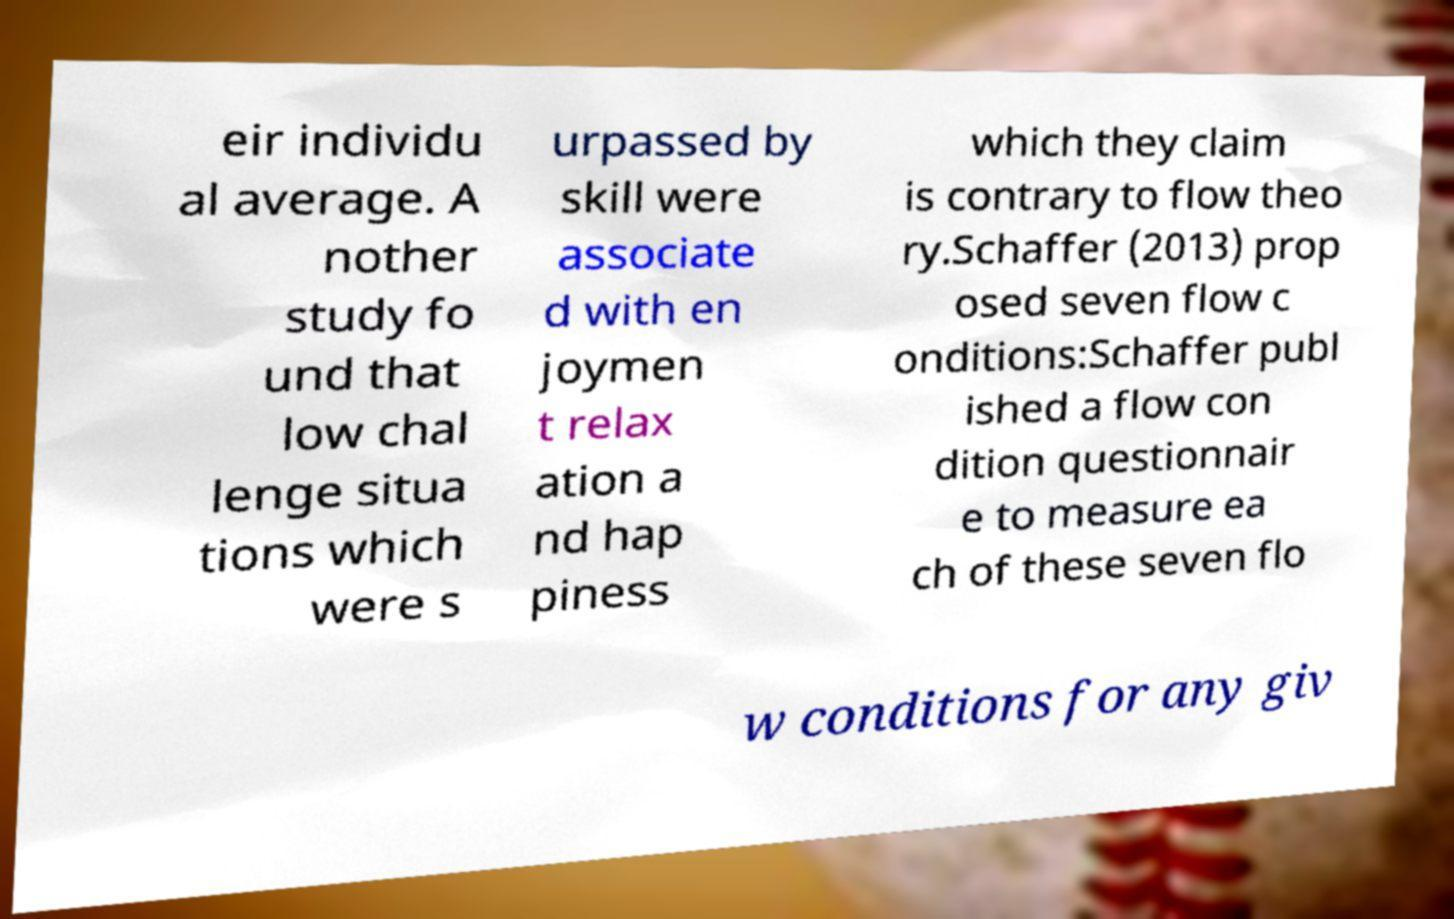For documentation purposes, I need the text within this image transcribed. Could you provide that? eir individu al average. A nother study fo und that low chal lenge situa tions which were s urpassed by skill were associate d with en joymen t relax ation a nd hap piness which they claim is contrary to flow theo ry.Schaffer (2013) prop osed seven flow c onditions:Schaffer publ ished a flow con dition questionnair e to measure ea ch of these seven flo w conditions for any giv 